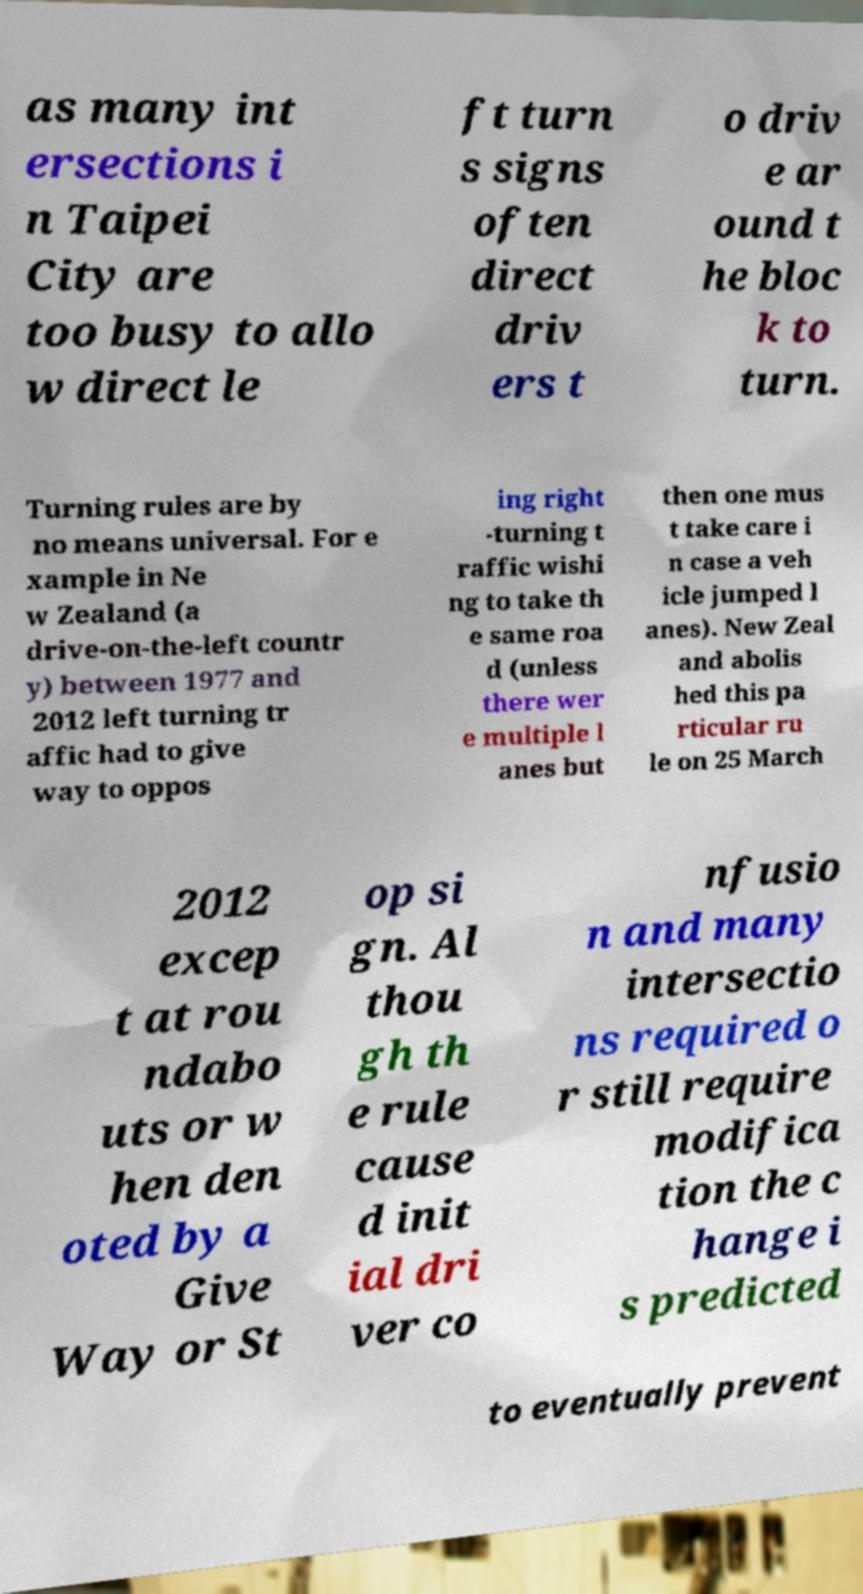For documentation purposes, I need the text within this image transcribed. Could you provide that? as many int ersections i n Taipei City are too busy to allo w direct le ft turn s signs often direct driv ers t o driv e ar ound t he bloc k to turn. Turning rules are by no means universal. For e xample in Ne w Zealand (a drive-on-the-left countr y) between 1977 and 2012 left turning tr affic had to give way to oppos ing right -turning t raffic wishi ng to take th e same roa d (unless there wer e multiple l anes but then one mus t take care i n case a veh icle jumped l anes). New Zeal and abolis hed this pa rticular ru le on 25 March 2012 excep t at rou ndabo uts or w hen den oted by a Give Way or St op si gn. Al thou gh th e rule cause d init ial dri ver co nfusio n and many intersectio ns required o r still require modifica tion the c hange i s predicted to eventually prevent 